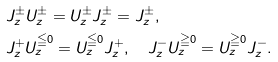<formula> <loc_0><loc_0><loc_500><loc_500>& J _ { z } ^ { \pm } U _ { z } ^ { \pm } = U _ { z } ^ { \pm } J _ { z } ^ { \pm } = J _ { z } ^ { \pm } , \\ & J _ { z } ^ { + } U _ { z } ^ { \leqq 0 } = U _ { z } ^ { \leqq 0 } J _ { z } ^ { + } , \quad J _ { z } ^ { - } U _ { z } ^ { \geqq 0 } = U _ { z } ^ { \geqq 0 } J _ { z } ^ { - } .</formula> 